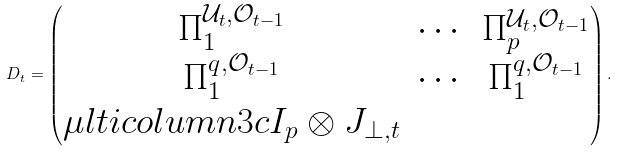Convert formula to latex. <formula><loc_0><loc_0><loc_500><loc_500>D _ { t } = \begin{pmatrix} \Pi _ { 1 } ^ { \mathcal { U } _ { t } , \mathcal { O } _ { t - 1 } } & \cdots & \Pi _ { p } ^ { \mathcal { U } _ { t } , \mathcal { O } _ { t - 1 } } \\ \Pi _ { 1 } ^ { q , \mathcal { O } _ { t - 1 } } & \cdots & \Pi _ { 1 } ^ { q , \mathcal { O } _ { t - 1 } } \\ \mu l t i c o l u m n { 3 } { c } { I _ { p } \otimes J _ { \perp , t } } \end{pmatrix} .</formula> 